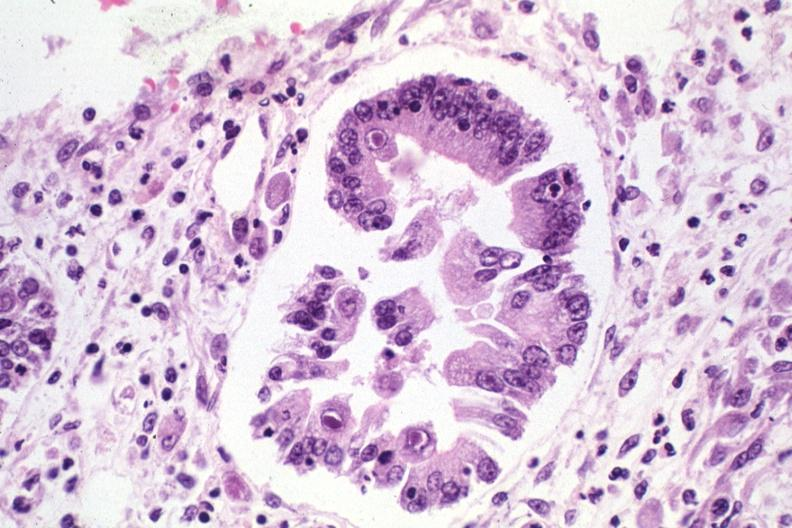s gastrointestinal present?
Answer the question using a single word or phrase. Yes 